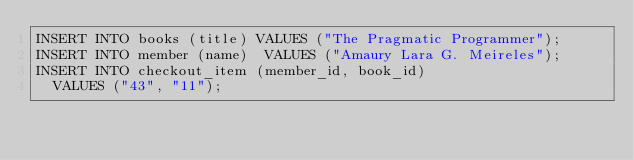Convert code to text. <code><loc_0><loc_0><loc_500><loc_500><_SQL_>INSERT INTO books (title) VALUES ("The Pragmatic Programmer");
INSERT INTO member (name)  VALUES ("Amaury Lara G. Meireles");
INSERT INTO checkout_item (member_id, book_id)
  VALUES ("43", "11");
</code> 